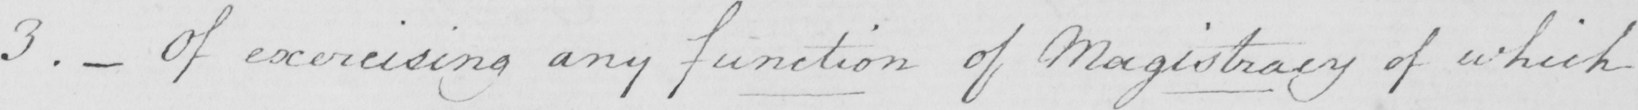Can you read and transcribe this handwriting? 3 .  _  Of exercising any function of Magistracy of which 